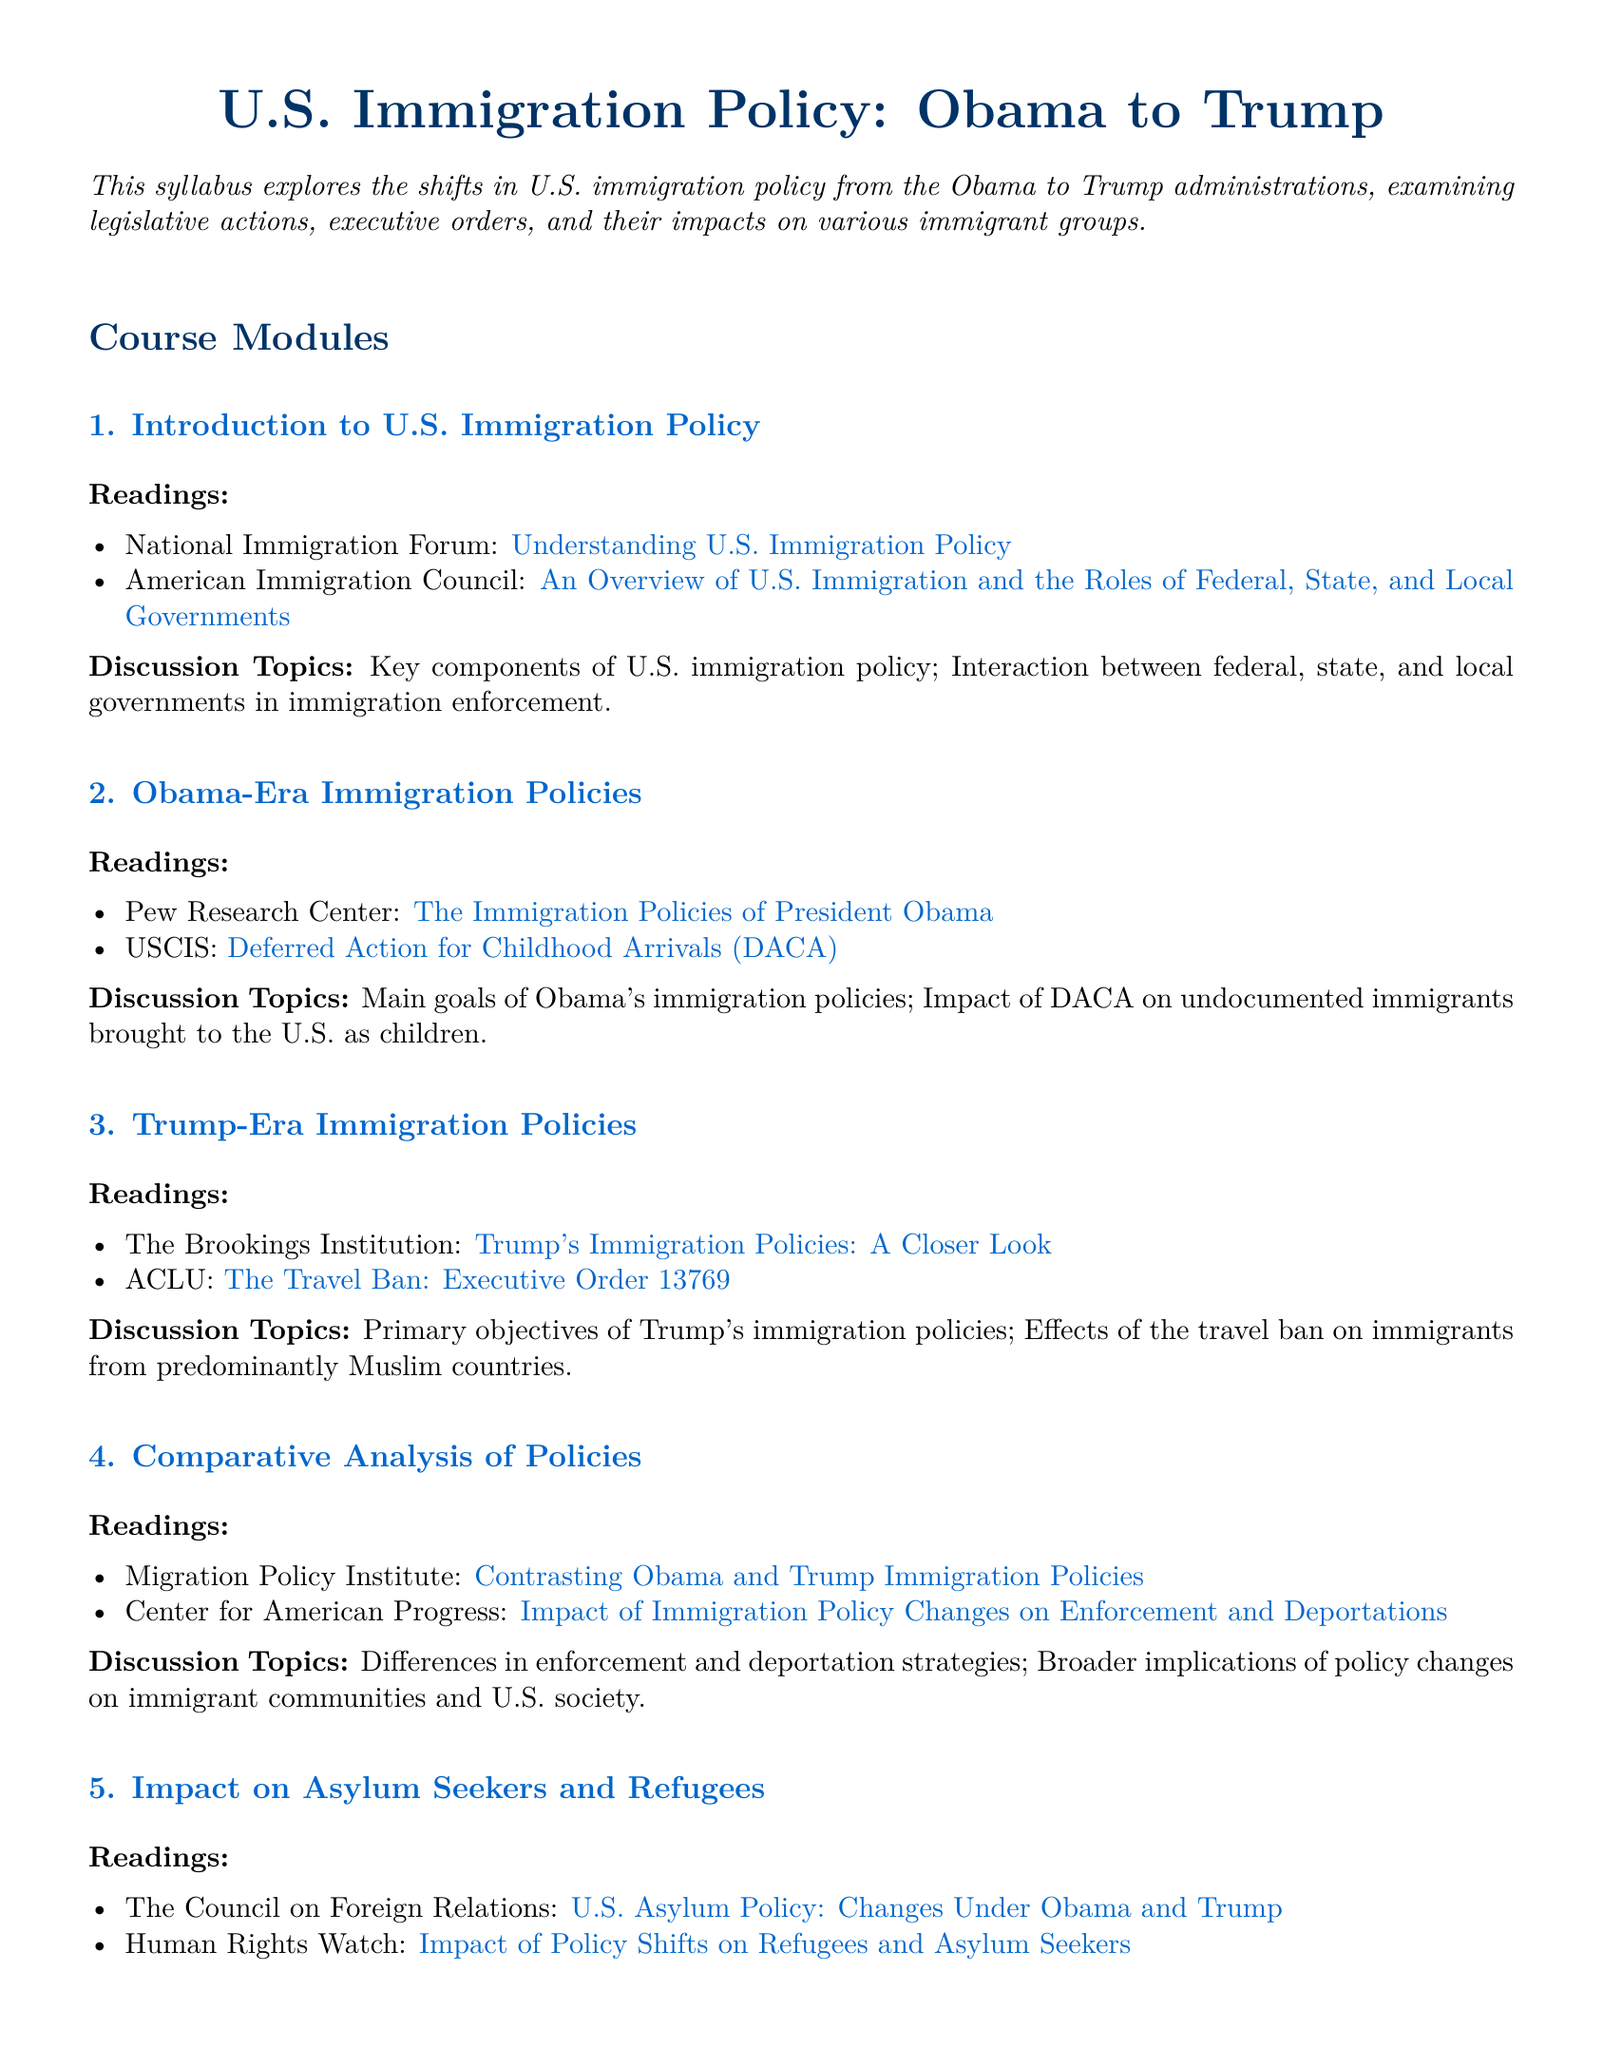what is the title of the syllabus? The title of the syllabus is prominently displayed at the beginning, which is "U.S. Immigration Policy: Obama to Trump".
Answer: U.S. Immigration Policy: Obama to Trump how many course modules are listed? The document outlines five course modules, which are listed sequentially.
Answer: 5 what does DACA stand for? DACA is mentioned in the context of Obama's immigration policies, representing Deferred Action for Childhood Arrivals.
Answer: Deferred Action for Childhood Arrivals which organization published information about the travel ban? The document includes an ACLU resource regarding the travel ban, indicating its source.
Answer: ACLU what is the main topic of the final module? The last module focuses on the impact of immigration policy changes on asylum seekers and refugees.
Answer: Impact on Asylum Seekers and Refugees which institution provided analysis on Trump's immigration policies? The document cites The Brookings Institution for a closer look at Trump's immigration policies.
Answer: The Brookings Institution what online resource provides an overview of U.S. immigration laws? One of the readings in the introduction module comes from the American Immigration Council, which provides an overview.
Answer: American Immigration Council name one key discussion topic related to Obama's immigration policies. The document specifies the impact of DACA as a key discussion topic related to Obama's policies.
Answer: Impact of DACA what is the primary focus of the comparative analysis module? The module is designed to address differences in enforcement and deportation strategies between the two administrations.
Answer: Differences in enforcement and deportation strategies 